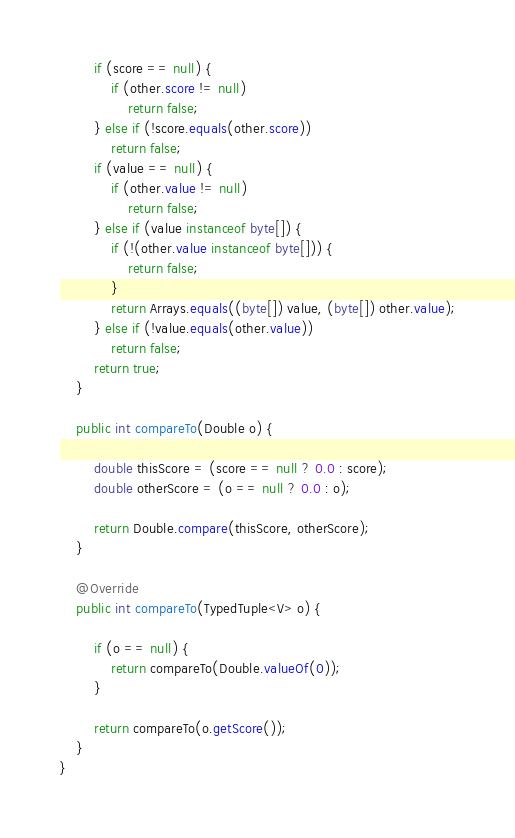Convert code to text. <code><loc_0><loc_0><loc_500><loc_500><_Java_>		if (score == null) {
			if (other.score != null)
				return false;
		} else if (!score.equals(other.score))
			return false;
		if (value == null) {
			if (other.value != null)
				return false;
		} else if (value instanceof byte[]) {
			if (!(other.value instanceof byte[])) {
				return false;
			}
			return Arrays.equals((byte[]) value, (byte[]) other.value);
		} else if (!value.equals(other.value))
			return false;
		return true;
	}

	public int compareTo(Double o) {

		double thisScore = (score == null ? 0.0 : score);
		double otherScore = (o == null ? 0.0 : o);

		return Double.compare(thisScore, otherScore);
	}

	@Override
	public int compareTo(TypedTuple<V> o) {

		if (o == null) {
			return compareTo(Double.valueOf(0));
		}

		return compareTo(o.getScore());
	}
}
</code> 